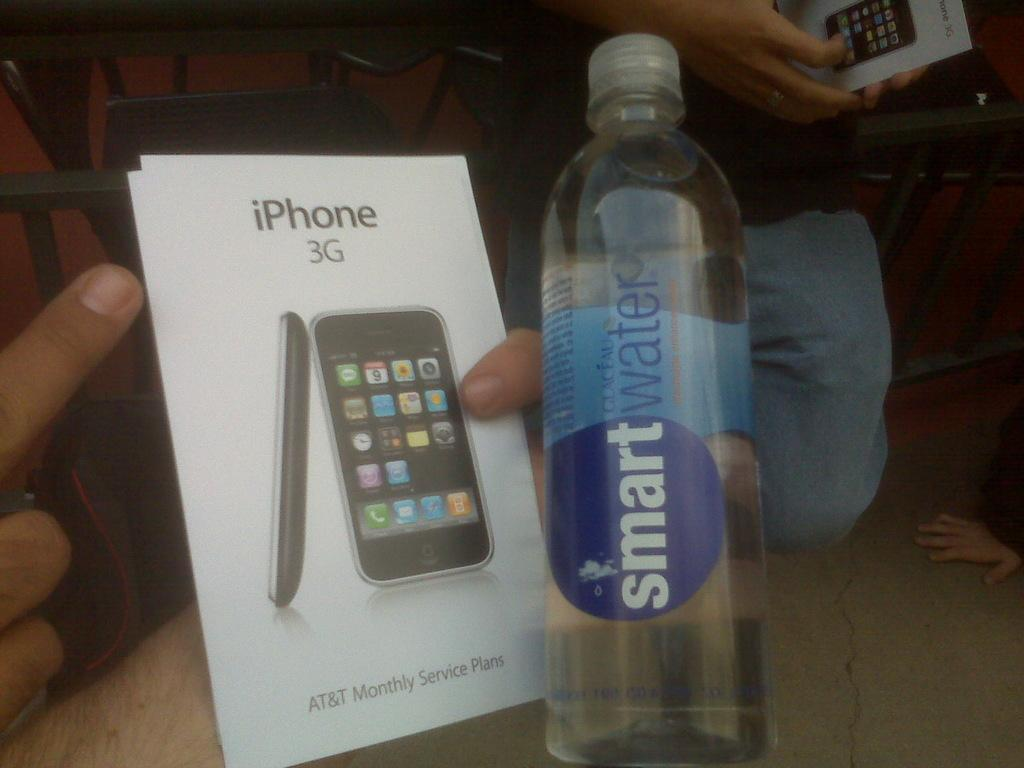<image>
Summarize the visual content of the image. An iPhone 3G box next to a bottle of smartwater. 